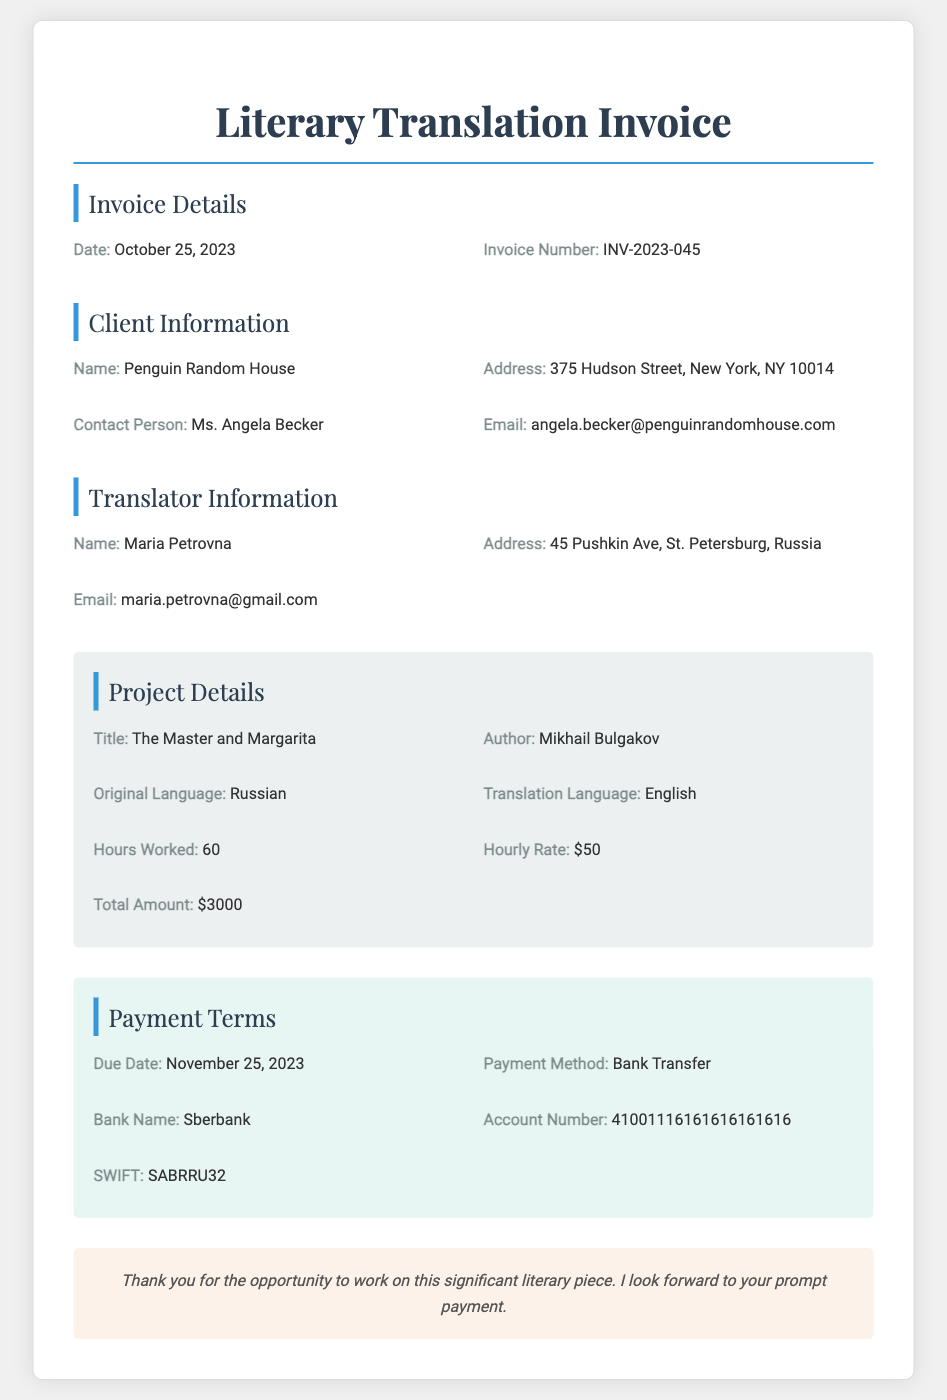What is the title of the work? The title of the work is specified in the project details section.
Answer: The Master and Margarita Who is the author? The author of the work is provided along with the title in the project details section.
Answer: Mikhail Bulgakov What is the hourly rate? The hourly rate is mentioned in the project details section of the document.
Answer: $50 How many hours were worked? The total hours worked are listed in the project details section of the invoice.
Answer: 60 What is the total amount due? The total amount is calculated and stated in the project details section.
Answer: $3000 What is the due date for payment? The due date is specified in the payment terms section of the document.
Answer: November 25, 2023 What payment method is mentioned? The method of payment is indicated in the payment terms section.
Answer: Bank Transfer Who is the contact person for the invoice? The contact person’s name is provided in the client information section.
Answer: Ms. Angela Becker What is the invoice number? The unique identifier for the invoice can be found in the invoice details section.
Answer: INV-2023-045 